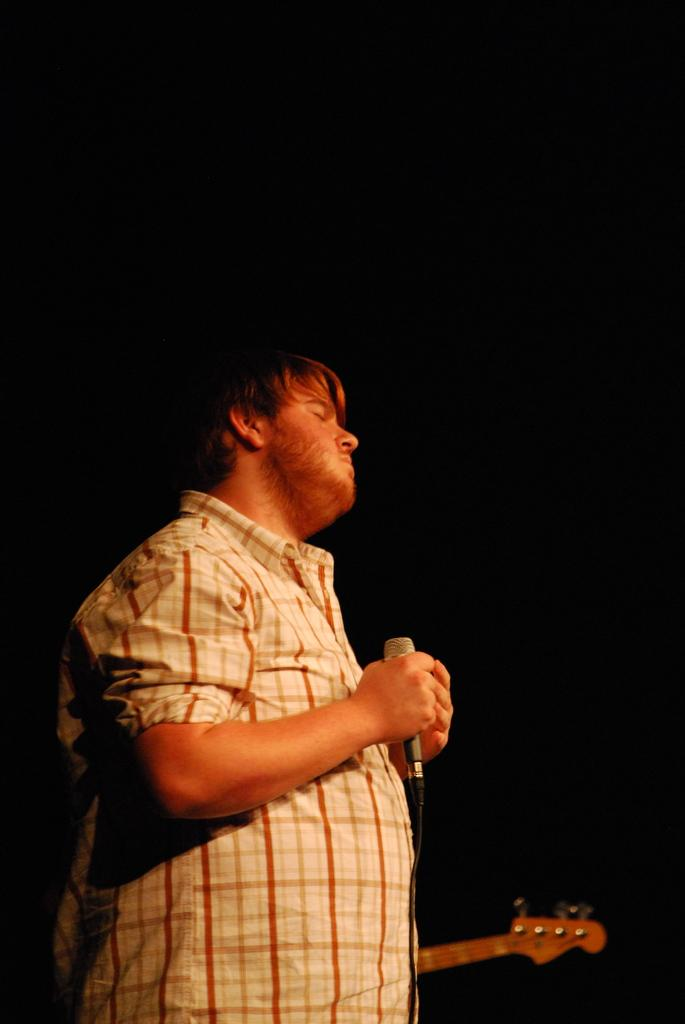What is the main subject of the image? The main subject of the image is a man. What is the man holding in his hand? The man is holding a microphone in his hand. What type of cream is the man using to control the microphone in the image? There is no cream present in the image, and the man is not using any cream to control the microphone. 